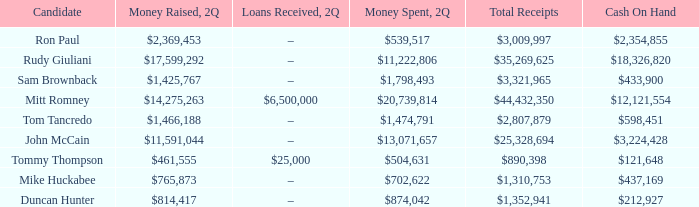Name the money raised when 2Q has money spent and 2Q is $874,042 $814,417. 